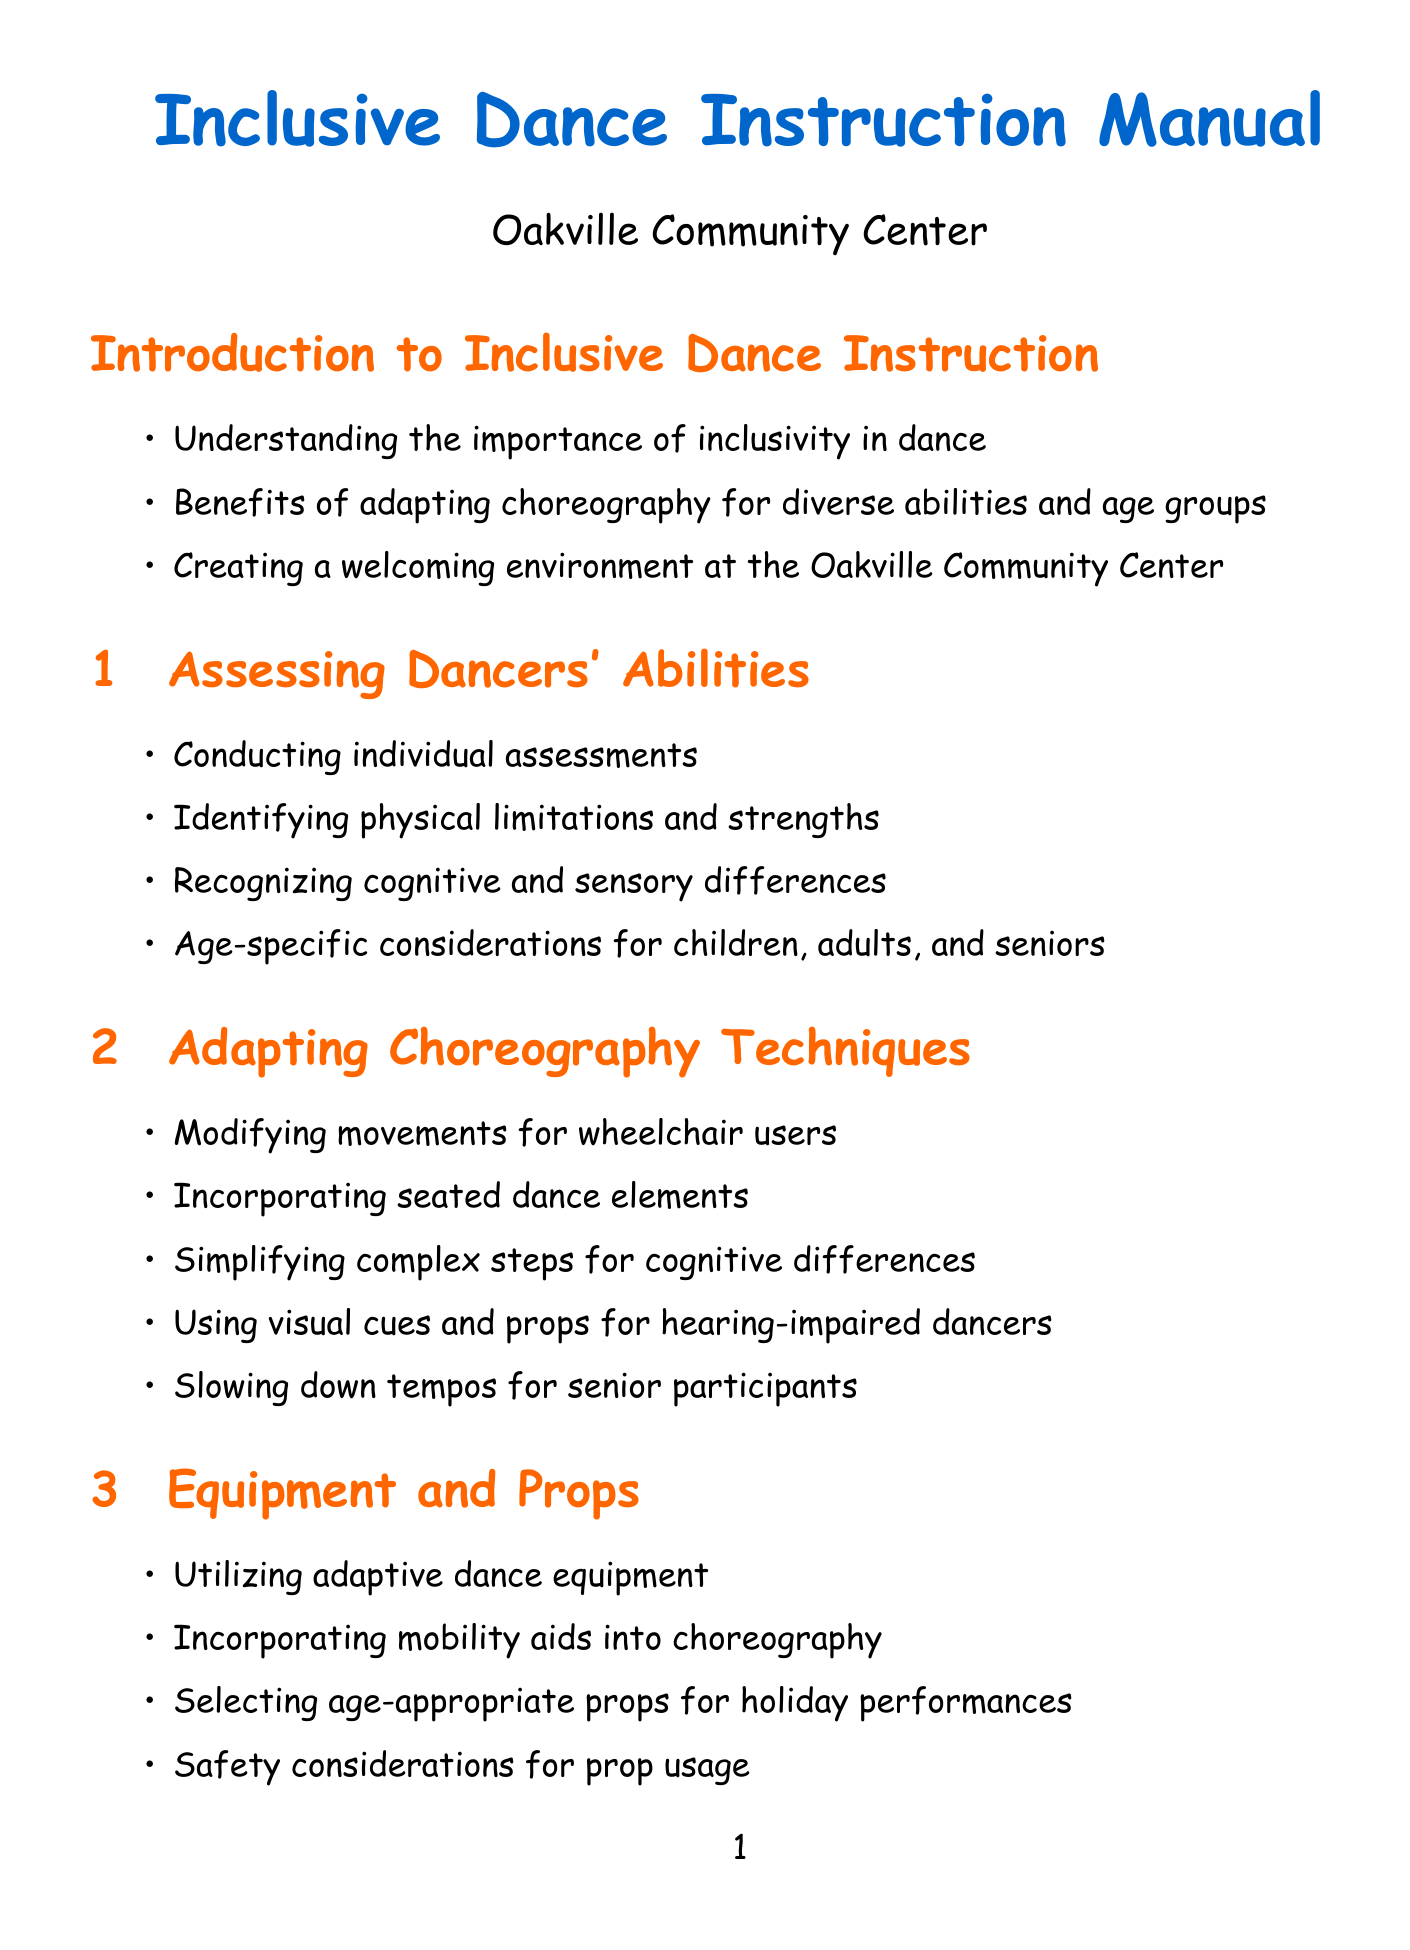What is the first section of the manual? The first section is titled "Introduction to Inclusive Dance Instruction," which outlines the manual's focus on inclusivity and the benefits of adapting choreography.
Answer: Introduction to Inclusive Dance Instruction What type of aids should be utilized in choreography? The manual suggests incorporating mobility aids into choreography as part of the adapting choreography techniques.
Answer: Mobility aids Which organization offers resources for inclusive dance instruction? The National Center for Disability and Dance is mentioned as a resource provider for workshops and online resources for inclusive dance instruction.
Answer: National Center for Disability and Dance What is one benefit of inclusive dance instruction mentioned in the manual? The manual includes various benefits, such as promoting body positivity and self-acceptance among participants.
Answer: Body positivity How many case studies are included in the document? There are two case studies provided in the document to illustrate practical applications of inclusive dance instruction.
Answer: 2 What safety consideration is emphasized in the manual? The manual emphasizes implementing proper warm-up and cool-down routines to ensure safety while dancing.
Answer: Warm-up and cool-down routines What is an example of a communication strategy mentioned? A strategy includes using clear and concise instructions to enhance understanding and participation among dancers.
Answer: Clear and concise instructions What type of music should be chosen for inclusive dance? The manual recommends choosing appropriate tempos for different ability levels in music selection and adaptation.
Answer: Appropriate tempos 